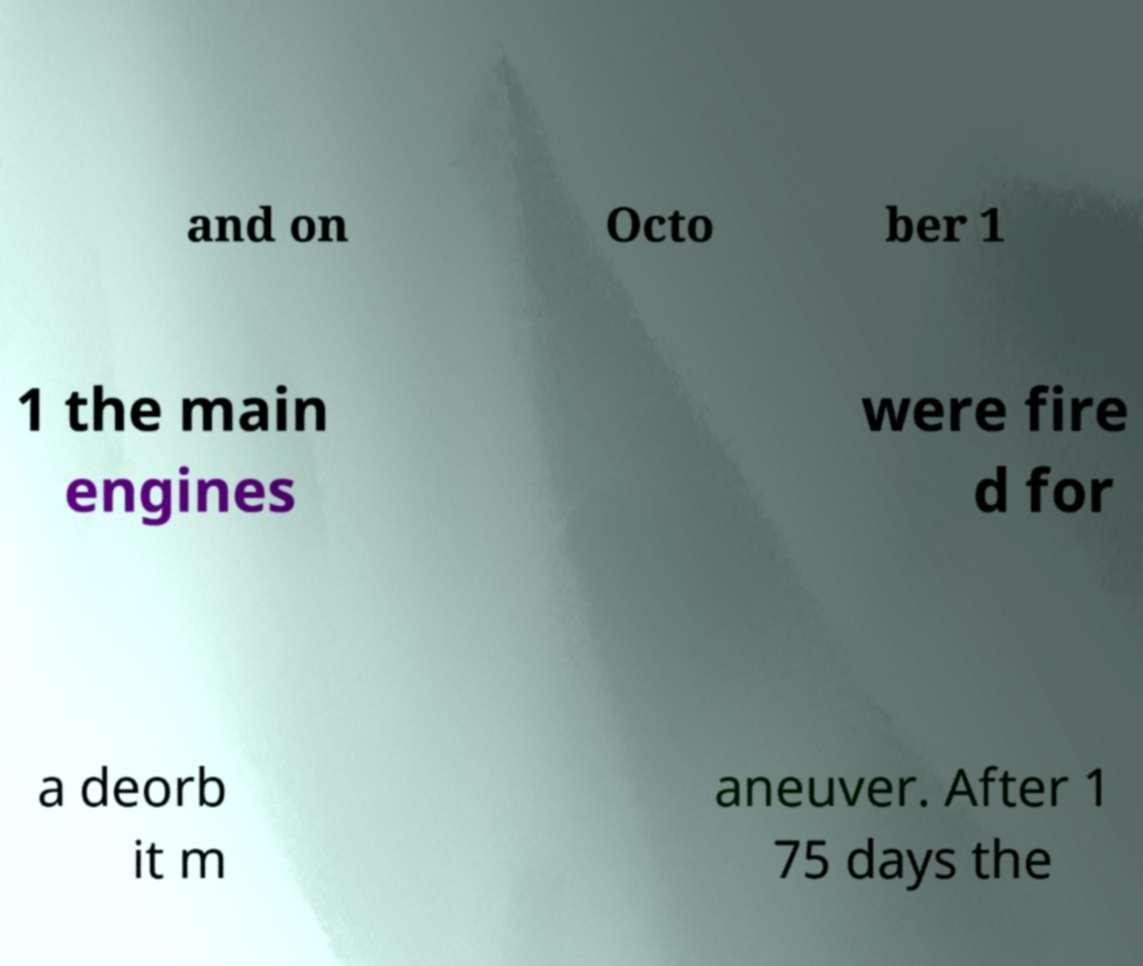For documentation purposes, I need the text within this image transcribed. Could you provide that? and on Octo ber 1 1 the main engines were fire d for a deorb it m aneuver. After 1 75 days the 